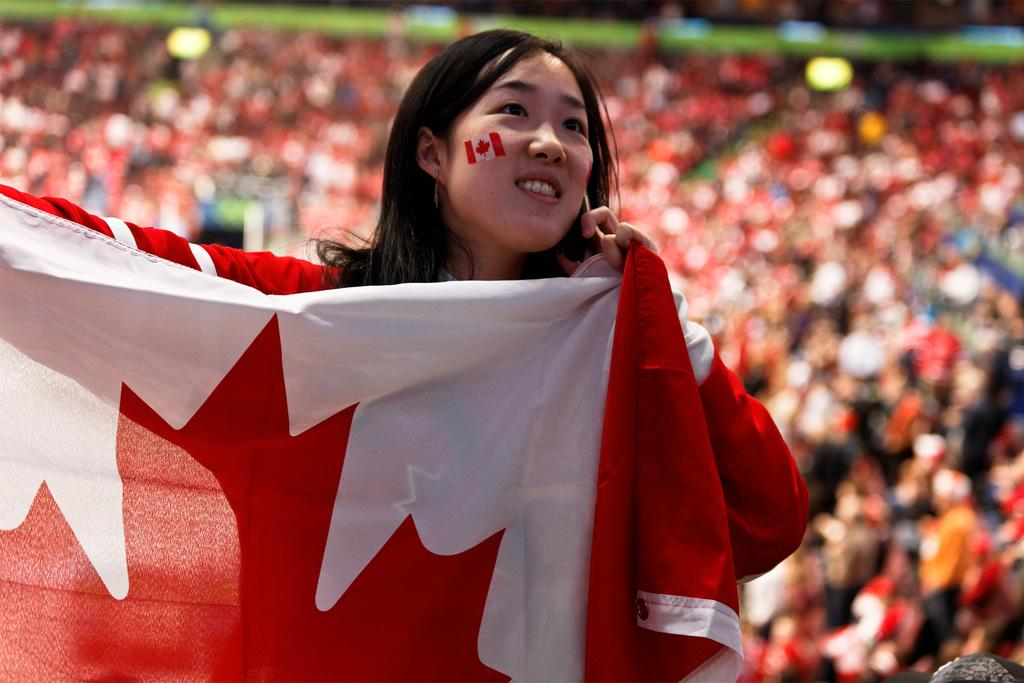Who is the main subject in the image? There is a woman in the image. What is the woman doing in the image? The woman is standing. What is the woman holding in the image? The woman is holding a red and white color cloth. What can be seen in the background of the image? There are people sitting in the background of the image. What type of chair is the lamp sitting on in the image? There is no chair or lamp present in the image. 